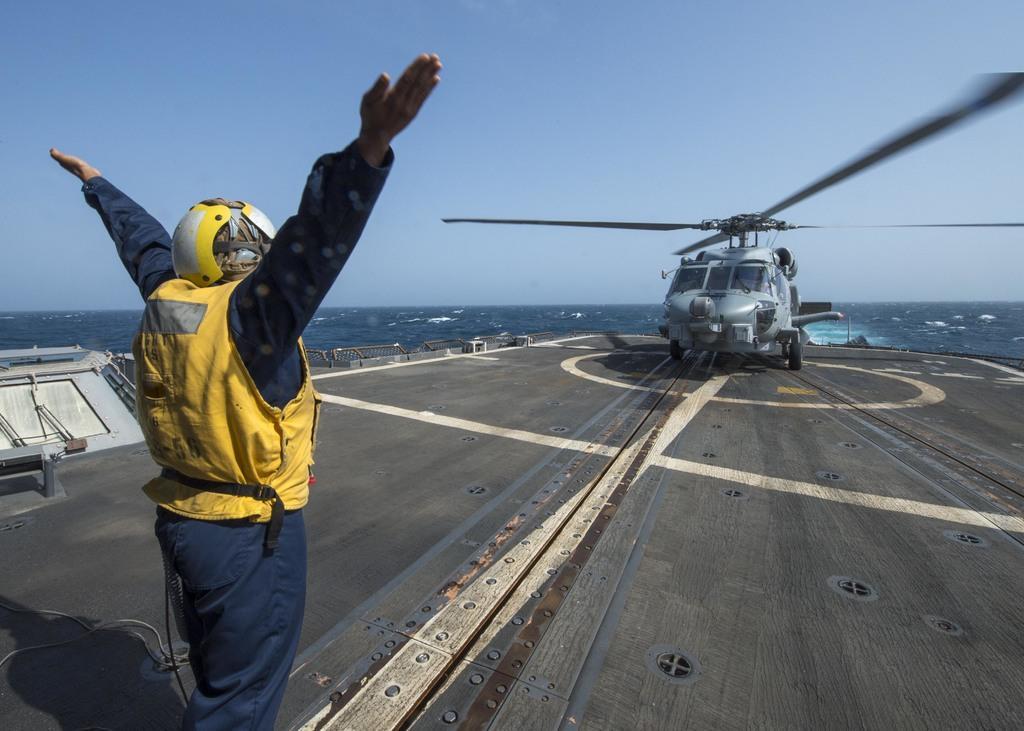Can you describe this image briefly? In the image we can see a man standing and facing back, he is wearing clothes and the helmet. In front of them man there is a helicopter. Here we can see the sea and the sky. 